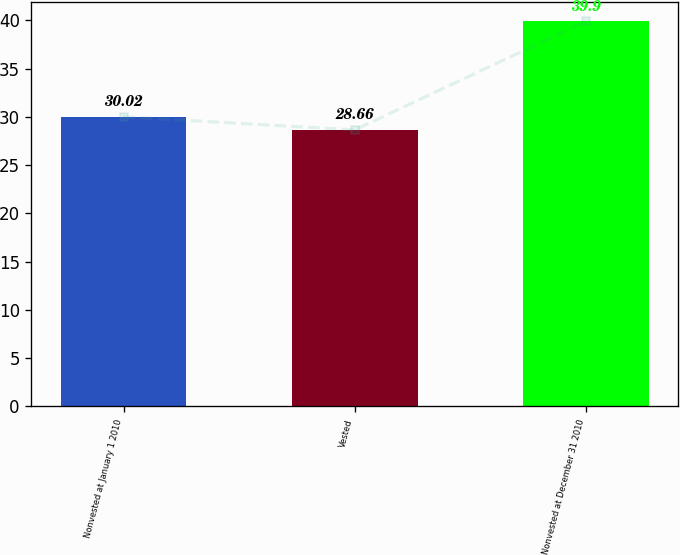<chart> <loc_0><loc_0><loc_500><loc_500><bar_chart><fcel>Nonvested at January 1 2010<fcel>Vested<fcel>Nonvested at December 31 2010<nl><fcel>30.02<fcel>28.66<fcel>39.9<nl></chart> 